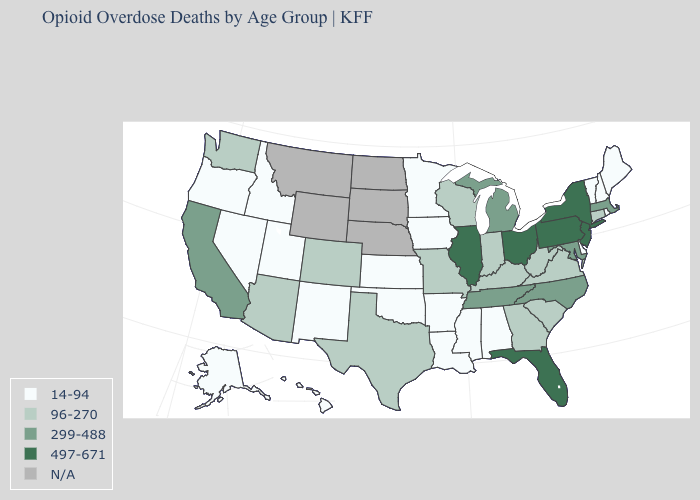Does the first symbol in the legend represent the smallest category?
Concise answer only. Yes. Name the states that have a value in the range N/A?
Quick response, please. Montana, Nebraska, North Dakota, South Dakota, Wyoming. Name the states that have a value in the range 96-270?
Give a very brief answer. Arizona, Colorado, Connecticut, Georgia, Indiana, Kentucky, Missouri, South Carolina, Texas, Virginia, Washington, West Virginia, Wisconsin. Which states have the lowest value in the USA?
Give a very brief answer. Alabama, Alaska, Arkansas, Delaware, Hawaii, Idaho, Iowa, Kansas, Louisiana, Maine, Minnesota, Mississippi, Nevada, New Hampshire, New Mexico, Oklahoma, Oregon, Rhode Island, Utah, Vermont. Name the states that have a value in the range N/A?
Short answer required. Montana, Nebraska, North Dakota, South Dakota, Wyoming. Does the map have missing data?
Short answer required. Yes. Among the states that border Wisconsin , which have the highest value?
Answer briefly. Illinois. Does the map have missing data?
Answer briefly. Yes. Among the states that border Connecticut , which have the highest value?
Keep it brief. New York. Does Illinois have the highest value in the USA?
Keep it brief. Yes. What is the value of Alaska?
Be succinct. 14-94. What is the lowest value in the USA?
Keep it brief. 14-94. Does Arizona have the highest value in the West?
Quick response, please. No. What is the highest value in the USA?
Give a very brief answer. 497-671. 